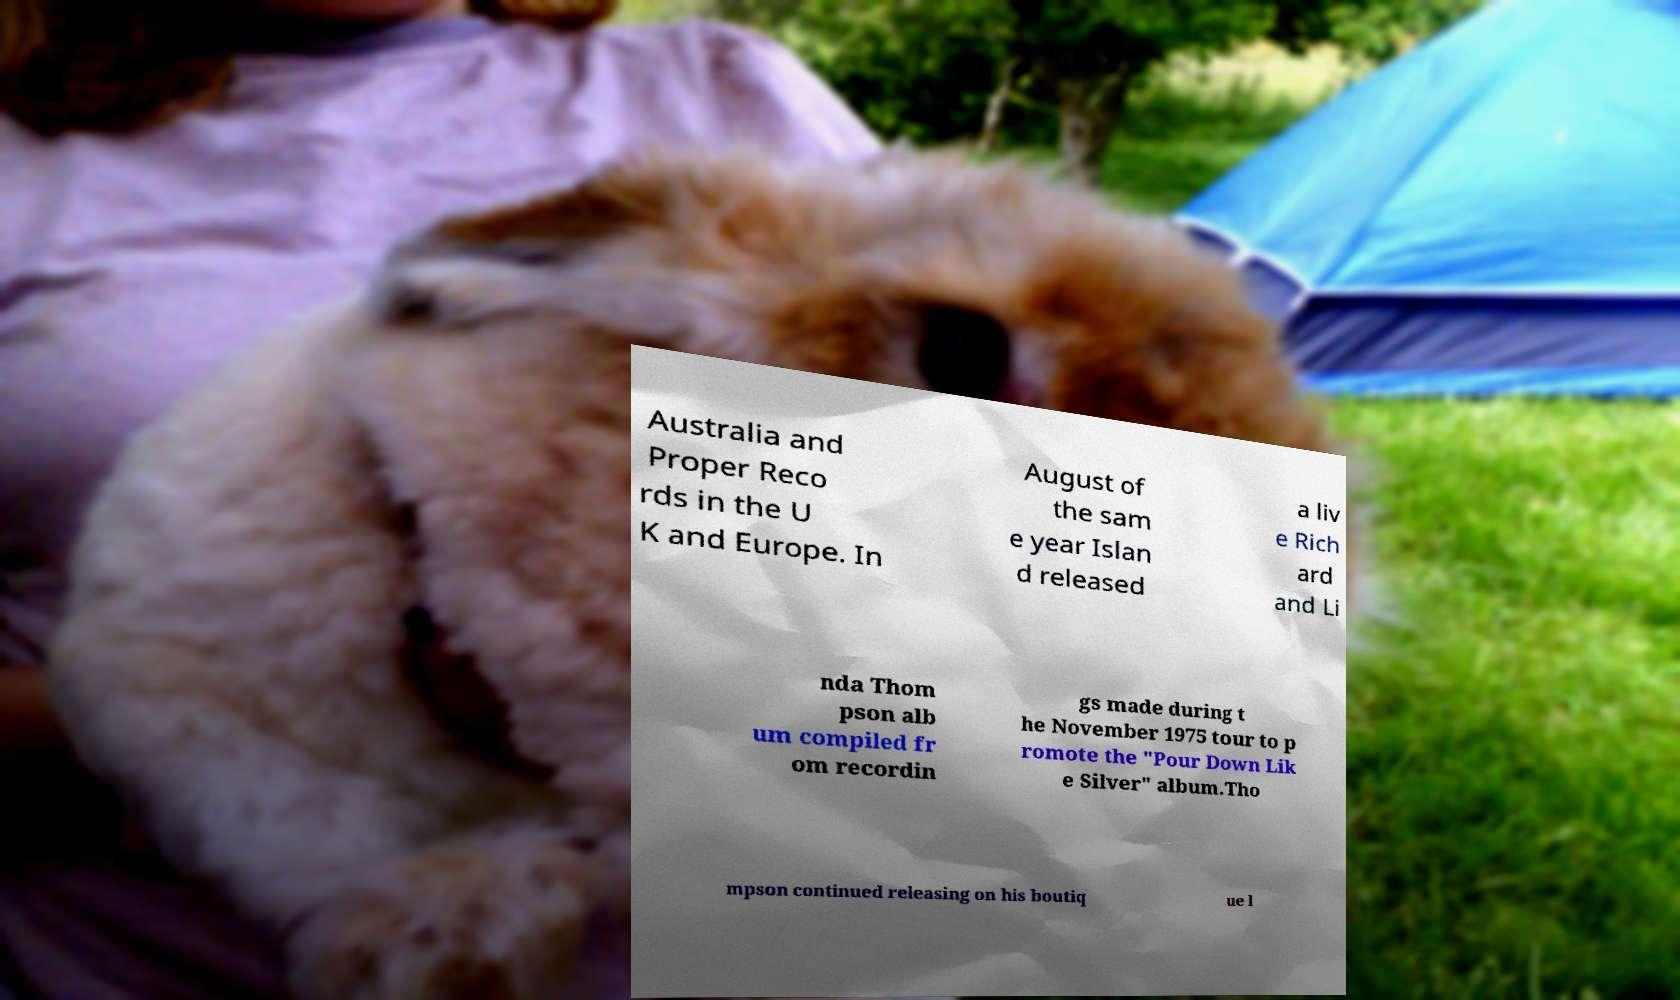Can you read and provide the text displayed in the image?This photo seems to have some interesting text. Can you extract and type it out for me? Australia and Proper Reco rds in the U K and Europe. In August of the sam e year Islan d released a liv e Rich ard and Li nda Thom pson alb um compiled fr om recordin gs made during t he November 1975 tour to p romote the "Pour Down Lik e Silver" album.Tho mpson continued releasing on his boutiq ue l 